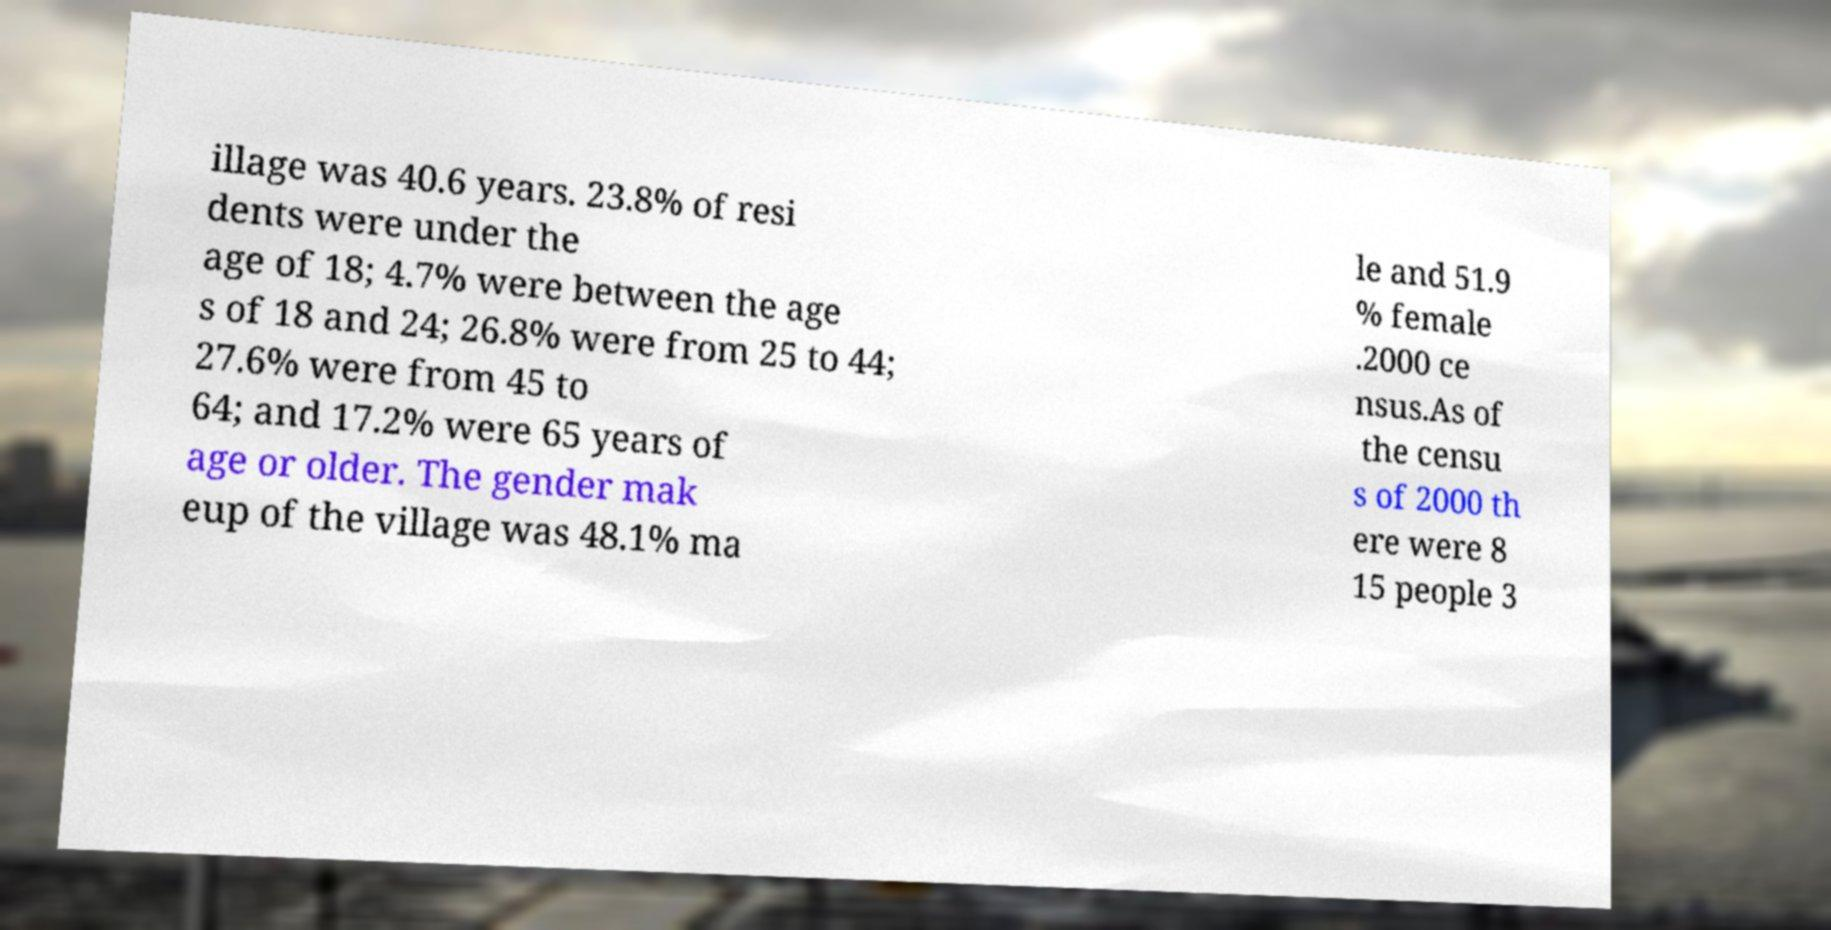Can you read and provide the text displayed in the image?This photo seems to have some interesting text. Can you extract and type it out for me? illage was 40.6 years. 23.8% of resi dents were under the age of 18; 4.7% were between the age s of 18 and 24; 26.8% were from 25 to 44; 27.6% were from 45 to 64; and 17.2% were 65 years of age or older. The gender mak eup of the village was 48.1% ma le and 51.9 % female .2000 ce nsus.As of the censu s of 2000 th ere were 8 15 people 3 